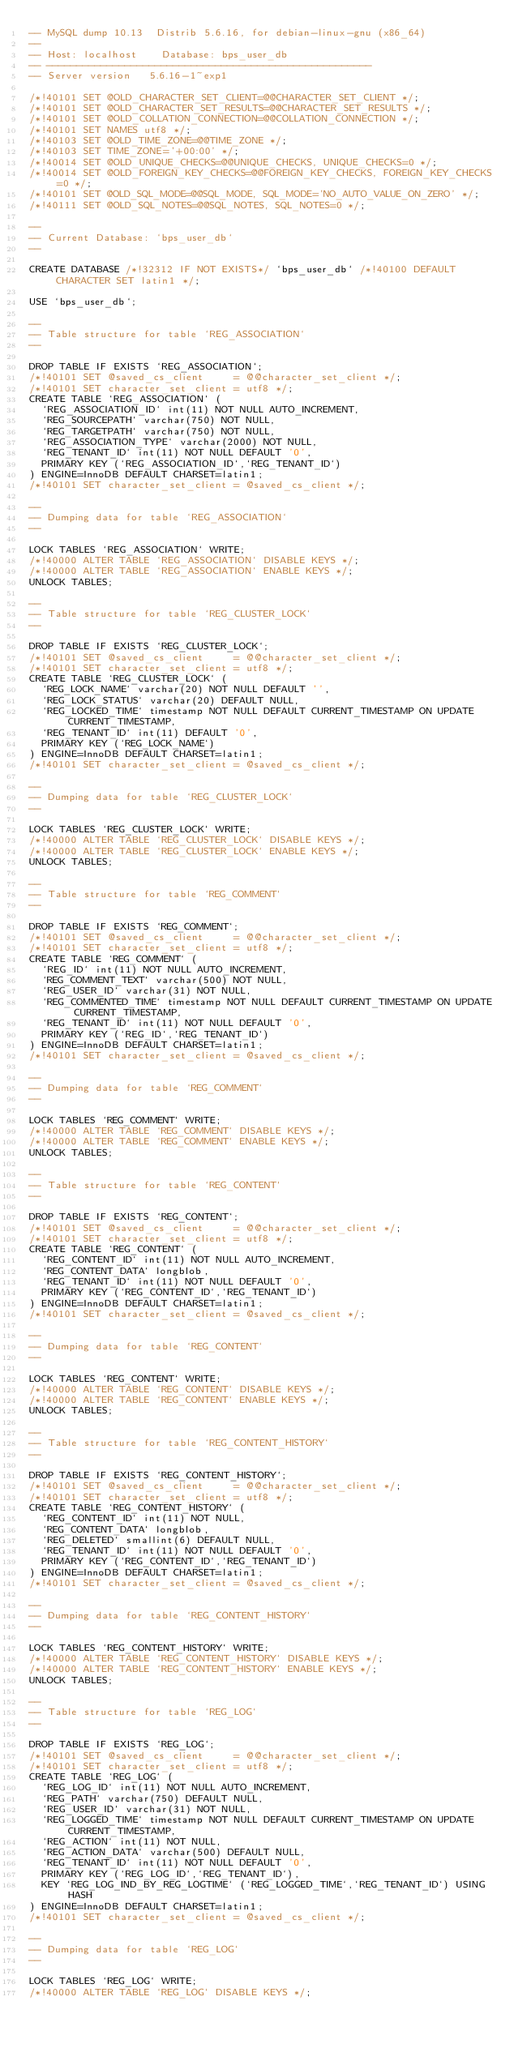<code> <loc_0><loc_0><loc_500><loc_500><_SQL_>-- MySQL dump 10.13  Distrib 5.6.16, for debian-linux-gnu (x86_64)
--
-- Host: localhost    Database: bps_user_db
-- ------------------------------------------------------
-- Server version	5.6.16-1~exp1

/*!40101 SET @OLD_CHARACTER_SET_CLIENT=@@CHARACTER_SET_CLIENT */;
/*!40101 SET @OLD_CHARACTER_SET_RESULTS=@@CHARACTER_SET_RESULTS */;
/*!40101 SET @OLD_COLLATION_CONNECTION=@@COLLATION_CONNECTION */;
/*!40101 SET NAMES utf8 */;
/*!40103 SET @OLD_TIME_ZONE=@@TIME_ZONE */;
/*!40103 SET TIME_ZONE='+00:00' */;
/*!40014 SET @OLD_UNIQUE_CHECKS=@@UNIQUE_CHECKS, UNIQUE_CHECKS=0 */;
/*!40014 SET @OLD_FOREIGN_KEY_CHECKS=@@FOREIGN_KEY_CHECKS, FOREIGN_KEY_CHECKS=0 */;
/*!40101 SET @OLD_SQL_MODE=@@SQL_MODE, SQL_MODE='NO_AUTO_VALUE_ON_ZERO' */;
/*!40111 SET @OLD_SQL_NOTES=@@SQL_NOTES, SQL_NOTES=0 */;

--
-- Current Database: `bps_user_db`
--

CREATE DATABASE /*!32312 IF NOT EXISTS*/ `bps_user_db` /*!40100 DEFAULT CHARACTER SET latin1 */;

USE `bps_user_db`;

--
-- Table structure for table `REG_ASSOCIATION`
--

DROP TABLE IF EXISTS `REG_ASSOCIATION`;
/*!40101 SET @saved_cs_client     = @@character_set_client */;
/*!40101 SET character_set_client = utf8 */;
CREATE TABLE `REG_ASSOCIATION` (
  `REG_ASSOCIATION_ID` int(11) NOT NULL AUTO_INCREMENT,
  `REG_SOURCEPATH` varchar(750) NOT NULL,
  `REG_TARGETPATH` varchar(750) NOT NULL,
  `REG_ASSOCIATION_TYPE` varchar(2000) NOT NULL,
  `REG_TENANT_ID` int(11) NOT NULL DEFAULT '0',
  PRIMARY KEY (`REG_ASSOCIATION_ID`,`REG_TENANT_ID`)
) ENGINE=InnoDB DEFAULT CHARSET=latin1;
/*!40101 SET character_set_client = @saved_cs_client */;

--
-- Dumping data for table `REG_ASSOCIATION`
--

LOCK TABLES `REG_ASSOCIATION` WRITE;
/*!40000 ALTER TABLE `REG_ASSOCIATION` DISABLE KEYS */;
/*!40000 ALTER TABLE `REG_ASSOCIATION` ENABLE KEYS */;
UNLOCK TABLES;

--
-- Table structure for table `REG_CLUSTER_LOCK`
--

DROP TABLE IF EXISTS `REG_CLUSTER_LOCK`;
/*!40101 SET @saved_cs_client     = @@character_set_client */;
/*!40101 SET character_set_client = utf8 */;
CREATE TABLE `REG_CLUSTER_LOCK` (
  `REG_LOCK_NAME` varchar(20) NOT NULL DEFAULT '',
  `REG_LOCK_STATUS` varchar(20) DEFAULT NULL,
  `REG_LOCKED_TIME` timestamp NOT NULL DEFAULT CURRENT_TIMESTAMP ON UPDATE CURRENT_TIMESTAMP,
  `REG_TENANT_ID` int(11) DEFAULT '0',
  PRIMARY KEY (`REG_LOCK_NAME`)
) ENGINE=InnoDB DEFAULT CHARSET=latin1;
/*!40101 SET character_set_client = @saved_cs_client */;

--
-- Dumping data for table `REG_CLUSTER_LOCK`
--

LOCK TABLES `REG_CLUSTER_LOCK` WRITE;
/*!40000 ALTER TABLE `REG_CLUSTER_LOCK` DISABLE KEYS */;
/*!40000 ALTER TABLE `REG_CLUSTER_LOCK` ENABLE KEYS */;
UNLOCK TABLES;

--
-- Table structure for table `REG_COMMENT`
--

DROP TABLE IF EXISTS `REG_COMMENT`;
/*!40101 SET @saved_cs_client     = @@character_set_client */;
/*!40101 SET character_set_client = utf8 */;
CREATE TABLE `REG_COMMENT` (
  `REG_ID` int(11) NOT NULL AUTO_INCREMENT,
  `REG_COMMENT_TEXT` varchar(500) NOT NULL,
  `REG_USER_ID` varchar(31) NOT NULL,
  `REG_COMMENTED_TIME` timestamp NOT NULL DEFAULT CURRENT_TIMESTAMP ON UPDATE CURRENT_TIMESTAMP,
  `REG_TENANT_ID` int(11) NOT NULL DEFAULT '0',
  PRIMARY KEY (`REG_ID`,`REG_TENANT_ID`)
) ENGINE=InnoDB DEFAULT CHARSET=latin1;
/*!40101 SET character_set_client = @saved_cs_client */;

--
-- Dumping data for table `REG_COMMENT`
--

LOCK TABLES `REG_COMMENT` WRITE;
/*!40000 ALTER TABLE `REG_COMMENT` DISABLE KEYS */;
/*!40000 ALTER TABLE `REG_COMMENT` ENABLE KEYS */;
UNLOCK TABLES;

--
-- Table structure for table `REG_CONTENT`
--

DROP TABLE IF EXISTS `REG_CONTENT`;
/*!40101 SET @saved_cs_client     = @@character_set_client */;
/*!40101 SET character_set_client = utf8 */;
CREATE TABLE `REG_CONTENT` (
  `REG_CONTENT_ID` int(11) NOT NULL AUTO_INCREMENT,
  `REG_CONTENT_DATA` longblob,
  `REG_TENANT_ID` int(11) NOT NULL DEFAULT '0',
  PRIMARY KEY (`REG_CONTENT_ID`,`REG_TENANT_ID`)
) ENGINE=InnoDB DEFAULT CHARSET=latin1;
/*!40101 SET character_set_client = @saved_cs_client */;

--
-- Dumping data for table `REG_CONTENT`
--

LOCK TABLES `REG_CONTENT` WRITE;
/*!40000 ALTER TABLE `REG_CONTENT` DISABLE KEYS */;
/*!40000 ALTER TABLE `REG_CONTENT` ENABLE KEYS */;
UNLOCK TABLES;

--
-- Table structure for table `REG_CONTENT_HISTORY`
--

DROP TABLE IF EXISTS `REG_CONTENT_HISTORY`;
/*!40101 SET @saved_cs_client     = @@character_set_client */;
/*!40101 SET character_set_client = utf8 */;
CREATE TABLE `REG_CONTENT_HISTORY` (
  `REG_CONTENT_ID` int(11) NOT NULL,
  `REG_CONTENT_DATA` longblob,
  `REG_DELETED` smallint(6) DEFAULT NULL,
  `REG_TENANT_ID` int(11) NOT NULL DEFAULT '0',
  PRIMARY KEY (`REG_CONTENT_ID`,`REG_TENANT_ID`)
) ENGINE=InnoDB DEFAULT CHARSET=latin1;
/*!40101 SET character_set_client = @saved_cs_client */;

--
-- Dumping data for table `REG_CONTENT_HISTORY`
--

LOCK TABLES `REG_CONTENT_HISTORY` WRITE;
/*!40000 ALTER TABLE `REG_CONTENT_HISTORY` DISABLE KEYS */;
/*!40000 ALTER TABLE `REG_CONTENT_HISTORY` ENABLE KEYS */;
UNLOCK TABLES;

--
-- Table structure for table `REG_LOG`
--

DROP TABLE IF EXISTS `REG_LOG`;
/*!40101 SET @saved_cs_client     = @@character_set_client */;
/*!40101 SET character_set_client = utf8 */;
CREATE TABLE `REG_LOG` (
  `REG_LOG_ID` int(11) NOT NULL AUTO_INCREMENT,
  `REG_PATH` varchar(750) DEFAULT NULL,
  `REG_USER_ID` varchar(31) NOT NULL,
  `REG_LOGGED_TIME` timestamp NOT NULL DEFAULT CURRENT_TIMESTAMP ON UPDATE CURRENT_TIMESTAMP,
  `REG_ACTION` int(11) NOT NULL,
  `REG_ACTION_DATA` varchar(500) DEFAULT NULL,
  `REG_TENANT_ID` int(11) NOT NULL DEFAULT '0',
  PRIMARY KEY (`REG_LOG_ID`,`REG_TENANT_ID`),
  KEY `REG_LOG_IND_BY_REG_LOGTIME` (`REG_LOGGED_TIME`,`REG_TENANT_ID`) USING HASH
) ENGINE=InnoDB DEFAULT CHARSET=latin1;
/*!40101 SET character_set_client = @saved_cs_client */;

--
-- Dumping data for table `REG_LOG`
--

LOCK TABLES `REG_LOG` WRITE;
/*!40000 ALTER TABLE `REG_LOG` DISABLE KEYS */;</code> 